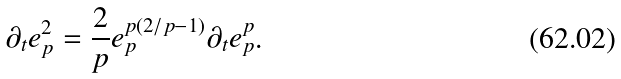<formula> <loc_0><loc_0><loc_500><loc_500>\partial _ { t } e _ { p } ^ { 2 } = \frac { 2 } { p } e _ { p } ^ { p ( 2 / p - 1 ) } \partial _ { t } e _ { p } ^ { p } .</formula> 